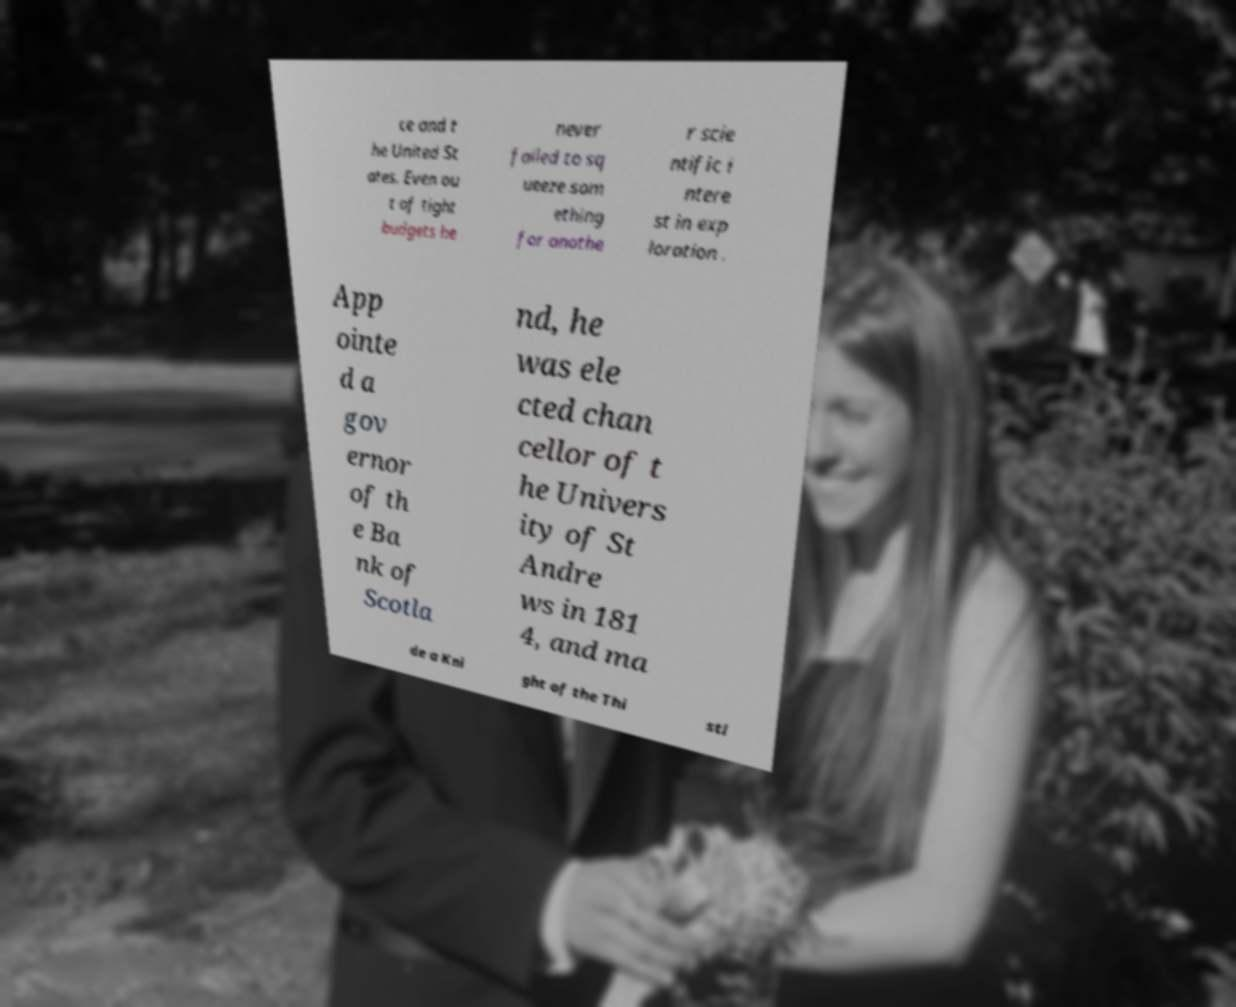I need the written content from this picture converted into text. Can you do that? ce and t he United St ates. Even ou t of tight budgets he never failed to sq ueeze som ething for anothe r scie ntific i ntere st in exp loration . App ointe d a gov ernor of th e Ba nk of Scotla nd, he was ele cted chan cellor of t he Univers ity of St Andre ws in 181 4, and ma de a Kni ght of the Thi stl 